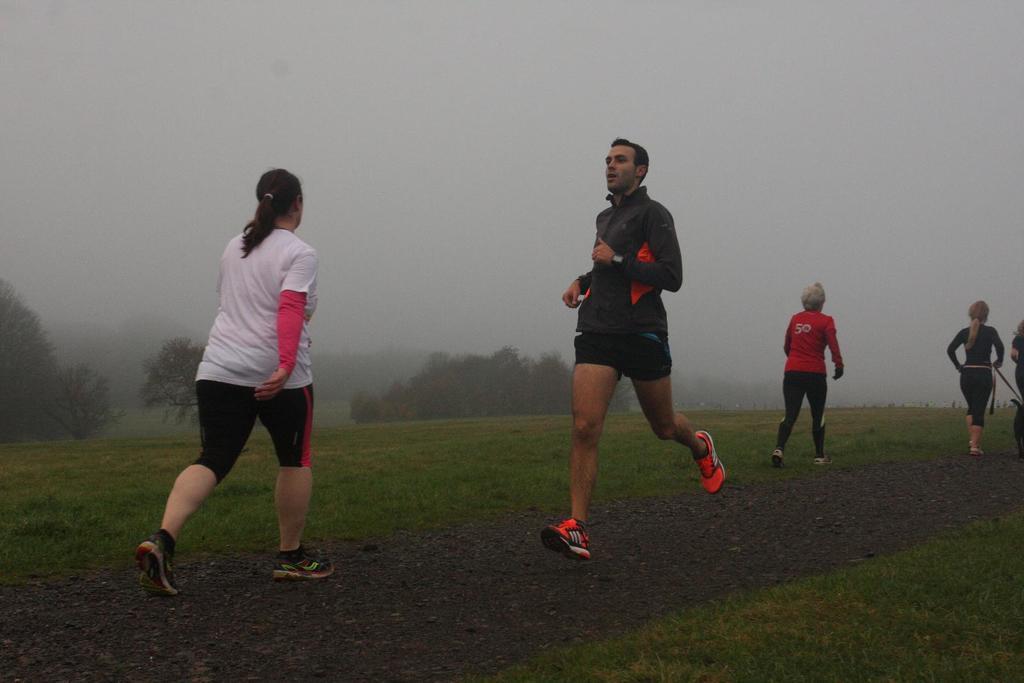How would you summarize this image in a sentence or two? In this picture we can see four persons are running, at the bottom there is grass, in the background we can see trees and fog, there is the sky at the top of the picture. 